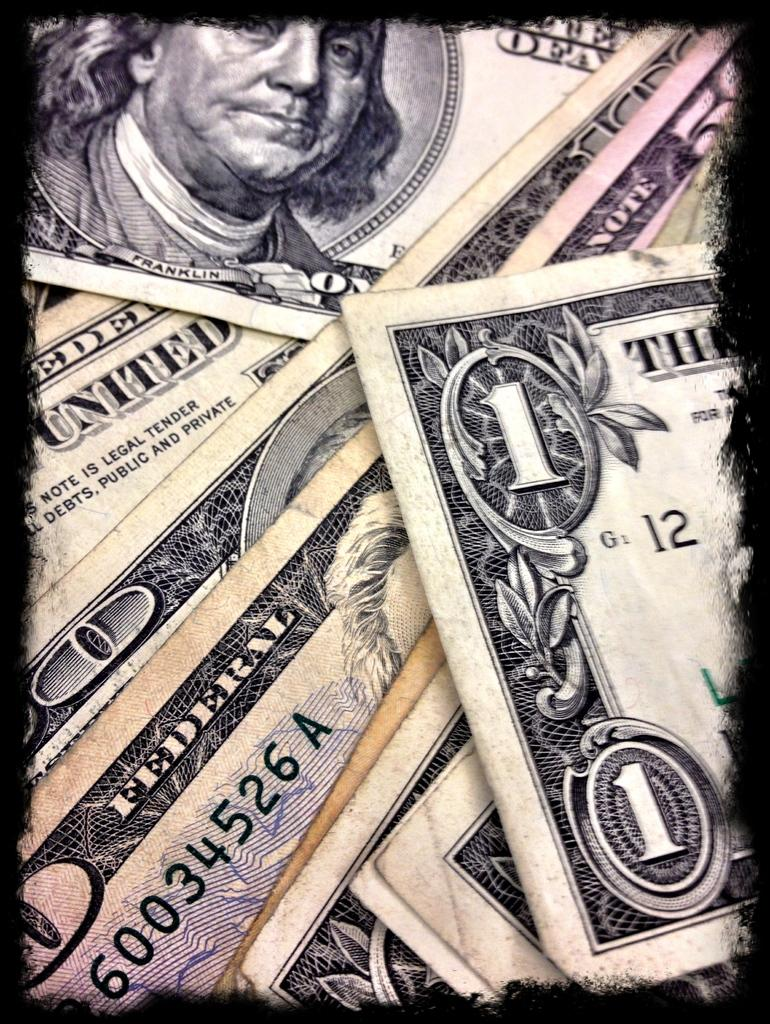What can be found on the currency notes in the image? There are numbers, text, an image of a person, and a design on the currency notes. Can you describe the image of the person on the currency notes? Unfortunately, the specific image of the person cannot be described without more information about the currency notes. What is the purpose of the text on the currency notes? The text on the currency notes likely serves to identify the issuing country, denomination, and other relevant information. How would you describe the design on the currency notes? The design on the currency notes may include intricate patterns, symbols, or other visual elements that are unique to the issuing country. What type of shock can be seen affecting the dad in the image? There is no dad or shock present in the image; it features currency notes with various design elements. 